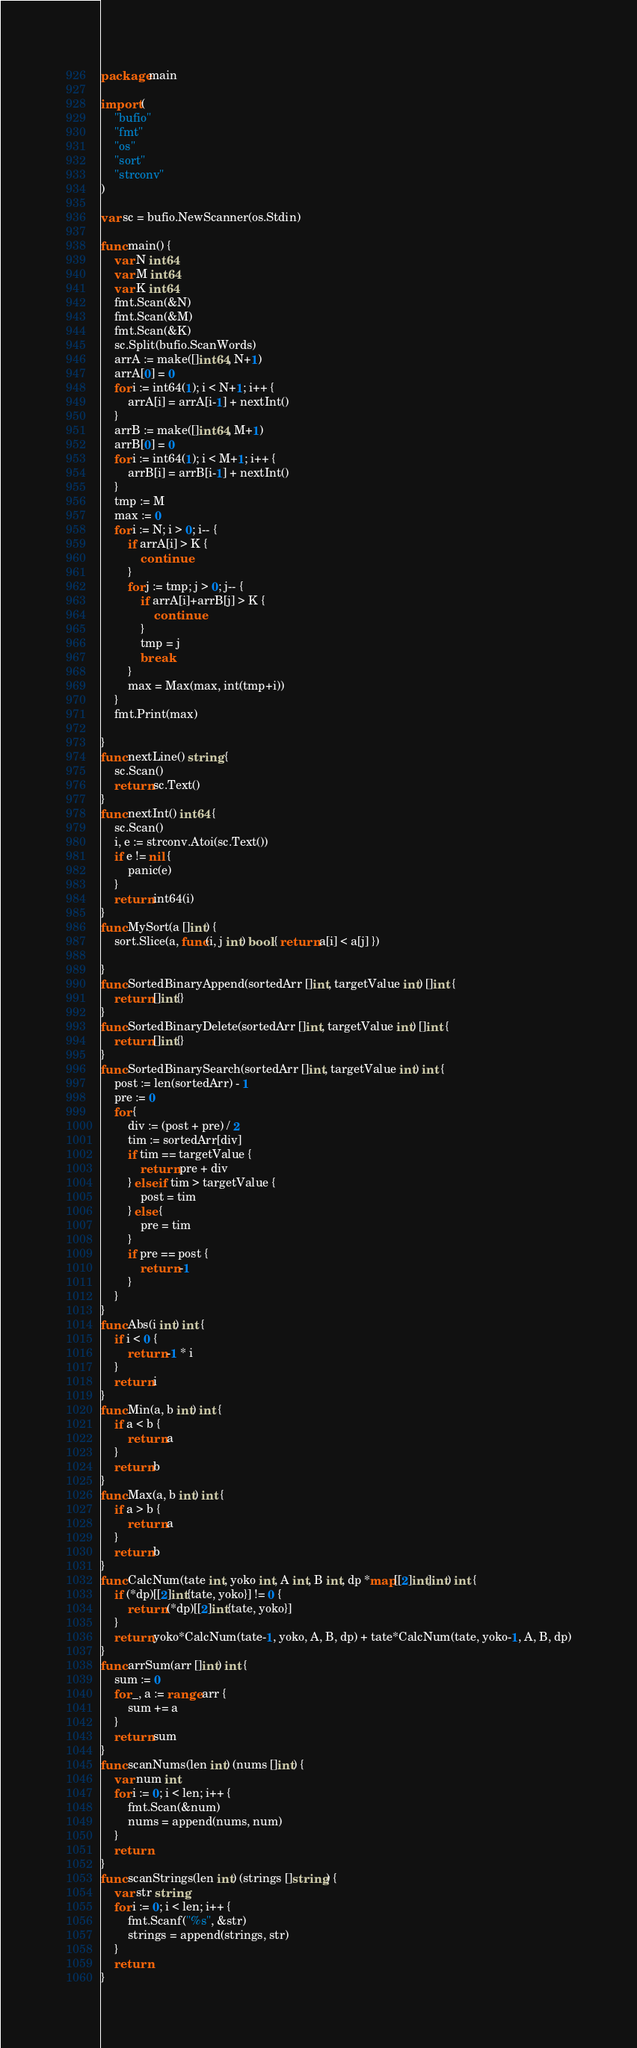Convert code to text. <code><loc_0><loc_0><loc_500><loc_500><_Go_>package main

import (
	"bufio"
	"fmt"
	"os"
	"sort"
	"strconv"
)

var sc = bufio.NewScanner(os.Stdin)

func main() {
	var N int64
	var M int64
	var K int64
	fmt.Scan(&N)
	fmt.Scan(&M)
	fmt.Scan(&K)
	sc.Split(bufio.ScanWords)
	arrA := make([]int64, N+1)
	arrA[0] = 0
	for i := int64(1); i < N+1; i++ {
		arrA[i] = arrA[i-1] + nextInt()
	}
	arrB := make([]int64, M+1)
	arrB[0] = 0
	for i := int64(1); i < M+1; i++ {
		arrB[i] = arrB[i-1] + nextInt()
	}
	tmp := M
	max := 0
	for i := N; i > 0; i-- {
		if arrA[i] > K {
			continue
		}
		for j := tmp; j > 0; j-- {
			if arrA[i]+arrB[j] > K {
				continue
			}
			tmp = j
			break
		}
		max = Max(max, int(tmp+i))
	}
	fmt.Print(max)

}
func nextLine() string {
	sc.Scan()
	return sc.Text()
}
func nextInt() int64 {
	sc.Scan()
	i, e := strconv.Atoi(sc.Text())
	if e != nil {
		panic(e)
	}
	return int64(i)
}
func MySort(a []int) {
	sort.Slice(a, func(i, j int) bool { return a[i] < a[j] })

}
func SortedBinaryAppend(sortedArr []int, targetValue int) []int {
	return []int{}
}
func SortedBinaryDelete(sortedArr []int, targetValue int) []int {
	return []int{}
}
func SortedBinarySearch(sortedArr []int, targetValue int) int {
	post := len(sortedArr) - 1
	pre := 0
	for {
		div := (post + pre) / 2
		tim := sortedArr[div]
		if tim == targetValue {
			return pre + div
		} else if tim > targetValue {
			post = tim
		} else {
			pre = tim
		}
		if pre == post {
			return -1
		}
	}
}
func Abs(i int) int {
	if i < 0 {
		return -1 * i
	}
	return i
}
func Min(a, b int) int {
	if a < b {
		return a
	}
	return b
}
func Max(a, b int) int {
	if a > b {
		return a
	}
	return b
}
func CalcNum(tate int, yoko int, A int, B int, dp *map[[2]int]int) int {
	if (*dp)[[2]int{tate, yoko}] != 0 {
		return (*dp)[[2]int{tate, yoko}]
	}
	return yoko*CalcNum(tate-1, yoko, A, B, dp) + tate*CalcNum(tate, yoko-1, A, B, dp)
}
func arrSum(arr []int) int {
	sum := 0
	for _, a := range arr {
		sum += a
	}
	return sum
}
func scanNums(len int) (nums []int) {
	var num int
	for i := 0; i < len; i++ {
		fmt.Scan(&num)
		nums = append(nums, num)
	}
	return
}
func scanStrings(len int) (strings []string) {
	var str string
	for i := 0; i < len; i++ {
		fmt.Scanf("%s", &str)
		strings = append(strings, str)
	}
	return
}
</code> 